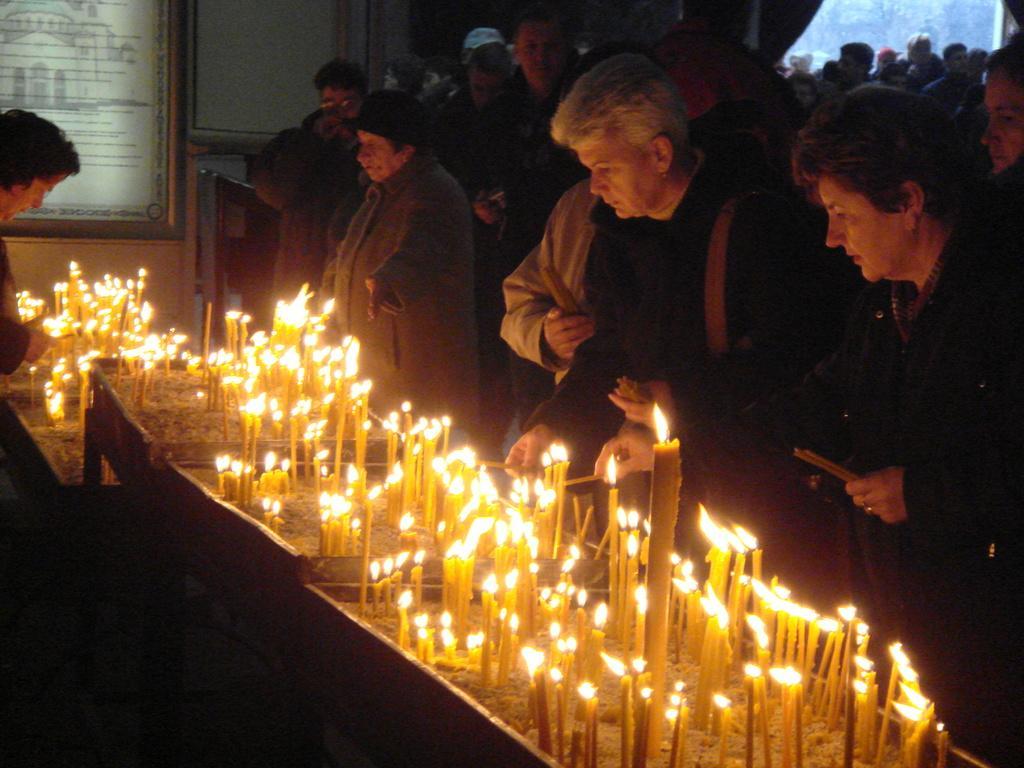Can you describe this image briefly? In the picture we can see some people are standing near the long table on it, we can see many candles with light and on the opposite side, we can see a woman standing and lighting the candles and behind the table we can see a wall with photo frame and something written on it. 